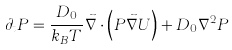Convert formula to latex. <formula><loc_0><loc_0><loc_500><loc_500>\partial _ { t } P = \frac { D _ { 0 } } { k _ { B } T } \vec { \nabla } \cdot \left ( P \vec { \nabla } U \right ) + D _ { 0 } \nabla ^ { 2 } P</formula> 